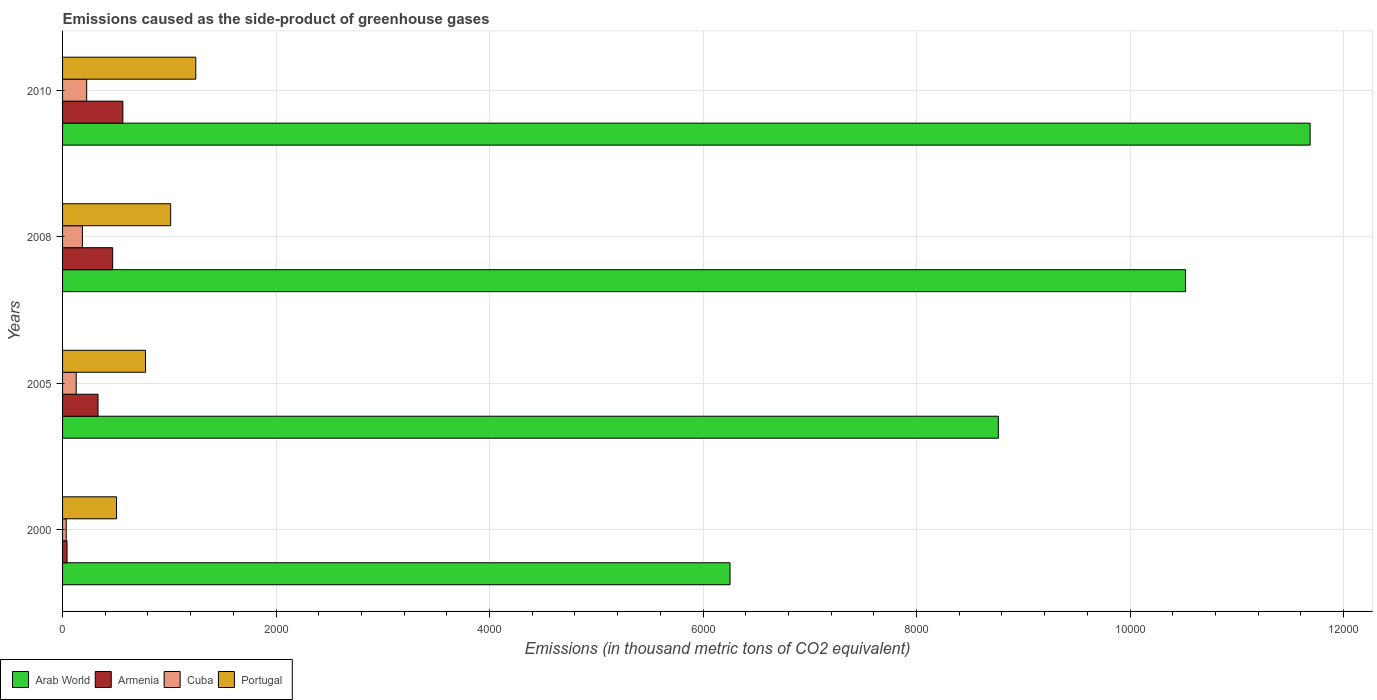How many groups of bars are there?
Keep it short and to the point. 4. What is the label of the 3rd group of bars from the top?
Provide a succinct answer. 2005. What is the emissions caused as the side-product of greenhouse gases in Armenia in 2005?
Ensure brevity in your answer.  332.2. Across all years, what is the maximum emissions caused as the side-product of greenhouse gases in Portugal?
Offer a terse response. 1248. Across all years, what is the minimum emissions caused as the side-product of greenhouse gases in Armenia?
Provide a short and direct response. 42. In which year was the emissions caused as the side-product of greenhouse gases in Cuba maximum?
Ensure brevity in your answer.  2010. What is the total emissions caused as the side-product of greenhouse gases in Cuba in the graph?
Your response must be concise. 573.9. What is the difference between the emissions caused as the side-product of greenhouse gases in Arab World in 2000 and that in 2005?
Offer a very short reply. -2513.8. What is the difference between the emissions caused as the side-product of greenhouse gases in Cuba in 2010 and the emissions caused as the side-product of greenhouse gases in Armenia in 2000?
Offer a terse response. 184. What is the average emissions caused as the side-product of greenhouse gases in Portugal per year?
Your answer should be compact. 885.73. In the year 2008, what is the difference between the emissions caused as the side-product of greenhouse gases in Cuba and emissions caused as the side-product of greenhouse gases in Arab World?
Give a very brief answer. -1.03e+04. In how many years, is the emissions caused as the side-product of greenhouse gases in Portugal greater than 2400 thousand metric tons?
Ensure brevity in your answer.  0. What is the ratio of the emissions caused as the side-product of greenhouse gases in Armenia in 2005 to that in 2008?
Keep it short and to the point. 0.71. What is the difference between the highest and the second highest emissions caused as the side-product of greenhouse gases in Arab World?
Make the answer very short. 1167.8. What is the difference between the highest and the lowest emissions caused as the side-product of greenhouse gases in Arab World?
Your answer should be very brief. 5434.4. In how many years, is the emissions caused as the side-product of greenhouse gases in Armenia greater than the average emissions caused as the side-product of greenhouse gases in Armenia taken over all years?
Your answer should be compact. 2. What does the 2nd bar from the top in 2000 represents?
Offer a very short reply. Cuba. What does the 1st bar from the bottom in 2000 represents?
Ensure brevity in your answer.  Arab World. How many bars are there?
Your response must be concise. 16. Are all the bars in the graph horizontal?
Offer a terse response. Yes. How many years are there in the graph?
Provide a short and direct response. 4. Does the graph contain grids?
Give a very brief answer. Yes. Where does the legend appear in the graph?
Make the answer very short. Bottom left. How many legend labels are there?
Give a very brief answer. 4. What is the title of the graph?
Provide a short and direct response. Emissions caused as the side-product of greenhouse gases. Does "East Asia (all income levels)" appear as one of the legend labels in the graph?
Your answer should be very brief. No. What is the label or title of the X-axis?
Your answer should be very brief. Emissions (in thousand metric tons of CO2 equivalent). What is the label or title of the Y-axis?
Offer a very short reply. Years. What is the Emissions (in thousand metric tons of CO2 equivalent) of Arab World in 2000?
Ensure brevity in your answer.  6252.6. What is the Emissions (in thousand metric tons of CO2 equivalent) in Cuba in 2000?
Your answer should be very brief. 34.2. What is the Emissions (in thousand metric tons of CO2 equivalent) of Portugal in 2000?
Make the answer very short. 505.3. What is the Emissions (in thousand metric tons of CO2 equivalent) in Arab World in 2005?
Keep it short and to the point. 8766.4. What is the Emissions (in thousand metric tons of CO2 equivalent) in Armenia in 2005?
Your answer should be compact. 332.2. What is the Emissions (in thousand metric tons of CO2 equivalent) of Cuba in 2005?
Your response must be concise. 127.8. What is the Emissions (in thousand metric tons of CO2 equivalent) of Portugal in 2005?
Offer a very short reply. 776.9. What is the Emissions (in thousand metric tons of CO2 equivalent) of Arab World in 2008?
Provide a short and direct response. 1.05e+04. What is the Emissions (in thousand metric tons of CO2 equivalent) in Armenia in 2008?
Provide a short and direct response. 469.6. What is the Emissions (in thousand metric tons of CO2 equivalent) of Cuba in 2008?
Provide a succinct answer. 185.9. What is the Emissions (in thousand metric tons of CO2 equivalent) in Portugal in 2008?
Your answer should be very brief. 1012.7. What is the Emissions (in thousand metric tons of CO2 equivalent) in Arab World in 2010?
Make the answer very short. 1.17e+04. What is the Emissions (in thousand metric tons of CO2 equivalent) of Armenia in 2010?
Provide a short and direct response. 565. What is the Emissions (in thousand metric tons of CO2 equivalent) in Cuba in 2010?
Ensure brevity in your answer.  226. What is the Emissions (in thousand metric tons of CO2 equivalent) in Portugal in 2010?
Your answer should be compact. 1248. Across all years, what is the maximum Emissions (in thousand metric tons of CO2 equivalent) of Arab World?
Offer a very short reply. 1.17e+04. Across all years, what is the maximum Emissions (in thousand metric tons of CO2 equivalent) of Armenia?
Keep it short and to the point. 565. Across all years, what is the maximum Emissions (in thousand metric tons of CO2 equivalent) in Cuba?
Provide a succinct answer. 226. Across all years, what is the maximum Emissions (in thousand metric tons of CO2 equivalent) of Portugal?
Provide a short and direct response. 1248. Across all years, what is the minimum Emissions (in thousand metric tons of CO2 equivalent) of Arab World?
Your answer should be very brief. 6252.6. Across all years, what is the minimum Emissions (in thousand metric tons of CO2 equivalent) of Cuba?
Ensure brevity in your answer.  34.2. Across all years, what is the minimum Emissions (in thousand metric tons of CO2 equivalent) in Portugal?
Make the answer very short. 505.3. What is the total Emissions (in thousand metric tons of CO2 equivalent) of Arab World in the graph?
Provide a succinct answer. 3.72e+04. What is the total Emissions (in thousand metric tons of CO2 equivalent) in Armenia in the graph?
Keep it short and to the point. 1408.8. What is the total Emissions (in thousand metric tons of CO2 equivalent) of Cuba in the graph?
Your response must be concise. 573.9. What is the total Emissions (in thousand metric tons of CO2 equivalent) in Portugal in the graph?
Provide a short and direct response. 3542.9. What is the difference between the Emissions (in thousand metric tons of CO2 equivalent) in Arab World in 2000 and that in 2005?
Offer a very short reply. -2513.8. What is the difference between the Emissions (in thousand metric tons of CO2 equivalent) of Armenia in 2000 and that in 2005?
Give a very brief answer. -290.2. What is the difference between the Emissions (in thousand metric tons of CO2 equivalent) of Cuba in 2000 and that in 2005?
Keep it short and to the point. -93.6. What is the difference between the Emissions (in thousand metric tons of CO2 equivalent) in Portugal in 2000 and that in 2005?
Ensure brevity in your answer.  -271.6. What is the difference between the Emissions (in thousand metric tons of CO2 equivalent) of Arab World in 2000 and that in 2008?
Provide a succinct answer. -4266.6. What is the difference between the Emissions (in thousand metric tons of CO2 equivalent) of Armenia in 2000 and that in 2008?
Your answer should be compact. -427.6. What is the difference between the Emissions (in thousand metric tons of CO2 equivalent) in Cuba in 2000 and that in 2008?
Offer a very short reply. -151.7. What is the difference between the Emissions (in thousand metric tons of CO2 equivalent) in Portugal in 2000 and that in 2008?
Your answer should be very brief. -507.4. What is the difference between the Emissions (in thousand metric tons of CO2 equivalent) in Arab World in 2000 and that in 2010?
Offer a very short reply. -5434.4. What is the difference between the Emissions (in thousand metric tons of CO2 equivalent) of Armenia in 2000 and that in 2010?
Give a very brief answer. -523. What is the difference between the Emissions (in thousand metric tons of CO2 equivalent) in Cuba in 2000 and that in 2010?
Provide a short and direct response. -191.8. What is the difference between the Emissions (in thousand metric tons of CO2 equivalent) of Portugal in 2000 and that in 2010?
Give a very brief answer. -742.7. What is the difference between the Emissions (in thousand metric tons of CO2 equivalent) of Arab World in 2005 and that in 2008?
Provide a short and direct response. -1752.8. What is the difference between the Emissions (in thousand metric tons of CO2 equivalent) of Armenia in 2005 and that in 2008?
Keep it short and to the point. -137.4. What is the difference between the Emissions (in thousand metric tons of CO2 equivalent) in Cuba in 2005 and that in 2008?
Offer a terse response. -58.1. What is the difference between the Emissions (in thousand metric tons of CO2 equivalent) of Portugal in 2005 and that in 2008?
Keep it short and to the point. -235.8. What is the difference between the Emissions (in thousand metric tons of CO2 equivalent) in Arab World in 2005 and that in 2010?
Give a very brief answer. -2920.6. What is the difference between the Emissions (in thousand metric tons of CO2 equivalent) of Armenia in 2005 and that in 2010?
Provide a short and direct response. -232.8. What is the difference between the Emissions (in thousand metric tons of CO2 equivalent) in Cuba in 2005 and that in 2010?
Offer a very short reply. -98.2. What is the difference between the Emissions (in thousand metric tons of CO2 equivalent) of Portugal in 2005 and that in 2010?
Your response must be concise. -471.1. What is the difference between the Emissions (in thousand metric tons of CO2 equivalent) of Arab World in 2008 and that in 2010?
Make the answer very short. -1167.8. What is the difference between the Emissions (in thousand metric tons of CO2 equivalent) in Armenia in 2008 and that in 2010?
Your answer should be compact. -95.4. What is the difference between the Emissions (in thousand metric tons of CO2 equivalent) of Cuba in 2008 and that in 2010?
Give a very brief answer. -40.1. What is the difference between the Emissions (in thousand metric tons of CO2 equivalent) in Portugal in 2008 and that in 2010?
Ensure brevity in your answer.  -235.3. What is the difference between the Emissions (in thousand metric tons of CO2 equivalent) of Arab World in 2000 and the Emissions (in thousand metric tons of CO2 equivalent) of Armenia in 2005?
Your answer should be very brief. 5920.4. What is the difference between the Emissions (in thousand metric tons of CO2 equivalent) in Arab World in 2000 and the Emissions (in thousand metric tons of CO2 equivalent) in Cuba in 2005?
Offer a terse response. 6124.8. What is the difference between the Emissions (in thousand metric tons of CO2 equivalent) in Arab World in 2000 and the Emissions (in thousand metric tons of CO2 equivalent) in Portugal in 2005?
Provide a short and direct response. 5475.7. What is the difference between the Emissions (in thousand metric tons of CO2 equivalent) of Armenia in 2000 and the Emissions (in thousand metric tons of CO2 equivalent) of Cuba in 2005?
Ensure brevity in your answer.  -85.8. What is the difference between the Emissions (in thousand metric tons of CO2 equivalent) of Armenia in 2000 and the Emissions (in thousand metric tons of CO2 equivalent) of Portugal in 2005?
Give a very brief answer. -734.9. What is the difference between the Emissions (in thousand metric tons of CO2 equivalent) in Cuba in 2000 and the Emissions (in thousand metric tons of CO2 equivalent) in Portugal in 2005?
Give a very brief answer. -742.7. What is the difference between the Emissions (in thousand metric tons of CO2 equivalent) of Arab World in 2000 and the Emissions (in thousand metric tons of CO2 equivalent) of Armenia in 2008?
Your answer should be very brief. 5783. What is the difference between the Emissions (in thousand metric tons of CO2 equivalent) in Arab World in 2000 and the Emissions (in thousand metric tons of CO2 equivalent) in Cuba in 2008?
Provide a succinct answer. 6066.7. What is the difference between the Emissions (in thousand metric tons of CO2 equivalent) in Arab World in 2000 and the Emissions (in thousand metric tons of CO2 equivalent) in Portugal in 2008?
Give a very brief answer. 5239.9. What is the difference between the Emissions (in thousand metric tons of CO2 equivalent) in Armenia in 2000 and the Emissions (in thousand metric tons of CO2 equivalent) in Cuba in 2008?
Ensure brevity in your answer.  -143.9. What is the difference between the Emissions (in thousand metric tons of CO2 equivalent) of Armenia in 2000 and the Emissions (in thousand metric tons of CO2 equivalent) of Portugal in 2008?
Provide a short and direct response. -970.7. What is the difference between the Emissions (in thousand metric tons of CO2 equivalent) in Cuba in 2000 and the Emissions (in thousand metric tons of CO2 equivalent) in Portugal in 2008?
Provide a succinct answer. -978.5. What is the difference between the Emissions (in thousand metric tons of CO2 equivalent) of Arab World in 2000 and the Emissions (in thousand metric tons of CO2 equivalent) of Armenia in 2010?
Ensure brevity in your answer.  5687.6. What is the difference between the Emissions (in thousand metric tons of CO2 equivalent) of Arab World in 2000 and the Emissions (in thousand metric tons of CO2 equivalent) of Cuba in 2010?
Make the answer very short. 6026.6. What is the difference between the Emissions (in thousand metric tons of CO2 equivalent) in Arab World in 2000 and the Emissions (in thousand metric tons of CO2 equivalent) in Portugal in 2010?
Your response must be concise. 5004.6. What is the difference between the Emissions (in thousand metric tons of CO2 equivalent) in Armenia in 2000 and the Emissions (in thousand metric tons of CO2 equivalent) in Cuba in 2010?
Your answer should be compact. -184. What is the difference between the Emissions (in thousand metric tons of CO2 equivalent) of Armenia in 2000 and the Emissions (in thousand metric tons of CO2 equivalent) of Portugal in 2010?
Your response must be concise. -1206. What is the difference between the Emissions (in thousand metric tons of CO2 equivalent) in Cuba in 2000 and the Emissions (in thousand metric tons of CO2 equivalent) in Portugal in 2010?
Your answer should be very brief. -1213.8. What is the difference between the Emissions (in thousand metric tons of CO2 equivalent) of Arab World in 2005 and the Emissions (in thousand metric tons of CO2 equivalent) of Armenia in 2008?
Keep it short and to the point. 8296.8. What is the difference between the Emissions (in thousand metric tons of CO2 equivalent) in Arab World in 2005 and the Emissions (in thousand metric tons of CO2 equivalent) in Cuba in 2008?
Ensure brevity in your answer.  8580.5. What is the difference between the Emissions (in thousand metric tons of CO2 equivalent) of Arab World in 2005 and the Emissions (in thousand metric tons of CO2 equivalent) of Portugal in 2008?
Provide a short and direct response. 7753.7. What is the difference between the Emissions (in thousand metric tons of CO2 equivalent) of Armenia in 2005 and the Emissions (in thousand metric tons of CO2 equivalent) of Cuba in 2008?
Make the answer very short. 146.3. What is the difference between the Emissions (in thousand metric tons of CO2 equivalent) of Armenia in 2005 and the Emissions (in thousand metric tons of CO2 equivalent) of Portugal in 2008?
Ensure brevity in your answer.  -680.5. What is the difference between the Emissions (in thousand metric tons of CO2 equivalent) in Cuba in 2005 and the Emissions (in thousand metric tons of CO2 equivalent) in Portugal in 2008?
Keep it short and to the point. -884.9. What is the difference between the Emissions (in thousand metric tons of CO2 equivalent) in Arab World in 2005 and the Emissions (in thousand metric tons of CO2 equivalent) in Armenia in 2010?
Your answer should be compact. 8201.4. What is the difference between the Emissions (in thousand metric tons of CO2 equivalent) of Arab World in 2005 and the Emissions (in thousand metric tons of CO2 equivalent) of Cuba in 2010?
Ensure brevity in your answer.  8540.4. What is the difference between the Emissions (in thousand metric tons of CO2 equivalent) in Arab World in 2005 and the Emissions (in thousand metric tons of CO2 equivalent) in Portugal in 2010?
Keep it short and to the point. 7518.4. What is the difference between the Emissions (in thousand metric tons of CO2 equivalent) of Armenia in 2005 and the Emissions (in thousand metric tons of CO2 equivalent) of Cuba in 2010?
Provide a succinct answer. 106.2. What is the difference between the Emissions (in thousand metric tons of CO2 equivalent) in Armenia in 2005 and the Emissions (in thousand metric tons of CO2 equivalent) in Portugal in 2010?
Your response must be concise. -915.8. What is the difference between the Emissions (in thousand metric tons of CO2 equivalent) in Cuba in 2005 and the Emissions (in thousand metric tons of CO2 equivalent) in Portugal in 2010?
Your response must be concise. -1120.2. What is the difference between the Emissions (in thousand metric tons of CO2 equivalent) in Arab World in 2008 and the Emissions (in thousand metric tons of CO2 equivalent) in Armenia in 2010?
Ensure brevity in your answer.  9954.2. What is the difference between the Emissions (in thousand metric tons of CO2 equivalent) of Arab World in 2008 and the Emissions (in thousand metric tons of CO2 equivalent) of Cuba in 2010?
Offer a terse response. 1.03e+04. What is the difference between the Emissions (in thousand metric tons of CO2 equivalent) in Arab World in 2008 and the Emissions (in thousand metric tons of CO2 equivalent) in Portugal in 2010?
Your answer should be compact. 9271.2. What is the difference between the Emissions (in thousand metric tons of CO2 equivalent) in Armenia in 2008 and the Emissions (in thousand metric tons of CO2 equivalent) in Cuba in 2010?
Your answer should be compact. 243.6. What is the difference between the Emissions (in thousand metric tons of CO2 equivalent) of Armenia in 2008 and the Emissions (in thousand metric tons of CO2 equivalent) of Portugal in 2010?
Offer a terse response. -778.4. What is the difference between the Emissions (in thousand metric tons of CO2 equivalent) in Cuba in 2008 and the Emissions (in thousand metric tons of CO2 equivalent) in Portugal in 2010?
Provide a short and direct response. -1062.1. What is the average Emissions (in thousand metric tons of CO2 equivalent) in Arab World per year?
Provide a succinct answer. 9306.3. What is the average Emissions (in thousand metric tons of CO2 equivalent) of Armenia per year?
Offer a very short reply. 352.2. What is the average Emissions (in thousand metric tons of CO2 equivalent) of Cuba per year?
Provide a short and direct response. 143.47. What is the average Emissions (in thousand metric tons of CO2 equivalent) of Portugal per year?
Provide a succinct answer. 885.73. In the year 2000, what is the difference between the Emissions (in thousand metric tons of CO2 equivalent) in Arab World and Emissions (in thousand metric tons of CO2 equivalent) in Armenia?
Your answer should be very brief. 6210.6. In the year 2000, what is the difference between the Emissions (in thousand metric tons of CO2 equivalent) of Arab World and Emissions (in thousand metric tons of CO2 equivalent) of Cuba?
Offer a terse response. 6218.4. In the year 2000, what is the difference between the Emissions (in thousand metric tons of CO2 equivalent) of Arab World and Emissions (in thousand metric tons of CO2 equivalent) of Portugal?
Make the answer very short. 5747.3. In the year 2000, what is the difference between the Emissions (in thousand metric tons of CO2 equivalent) in Armenia and Emissions (in thousand metric tons of CO2 equivalent) in Portugal?
Keep it short and to the point. -463.3. In the year 2000, what is the difference between the Emissions (in thousand metric tons of CO2 equivalent) in Cuba and Emissions (in thousand metric tons of CO2 equivalent) in Portugal?
Offer a terse response. -471.1. In the year 2005, what is the difference between the Emissions (in thousand metric tons of CO2 equivalent) of Arab World and Emissions (in thousand metric tons of CO2 equivalent) of Armenia?
Keep it short and to the point. 8434.2. In the year 2005, what is the difference between the Emissions (in thousand metric tons of CO2 equivalent) of Arab World and Emissions (in thousand metric tons of CO2 equivalent) of Cuba?
Offer a very short reply. 8638.6. In the year 2005, what is the difference between the Emissions (in thousand metric tons of CO2 equivalent) of Arab World and Emissions (in thousand metric tons of CO2 equivalent) of Portugal?
Provide a short and direct response. 7989.5. In the year 2005, what is the difference between the Emissions (in thousand metric tons of CO2 equivalent) of Armenia and Emissions (in thousand metric tons of CO2 equivalent) of Cuba?
Provide a short and direct response. 204.4. In the year 2005, what is the difference between the Emissions (in thousand metric tons of CO2 equivalent) in Armenia and Emissions (in thousand metric tons of CO2 equivalent) in Portugal?
Provide a short and direct response. -444.7. In the year 2005, what is the difference between the Emissions (in thousand metric tons of CO2 equivalent) in Cuba and Emissions (in thousand metric tons of CO2 equivalent) in Portugal?
Your answer should be very brief. -649.1. In the year 2008, what is the difference between the Emissions (in thousand metric tons of CO2 equivalent) of Arab World and Emissions (in thousand metric tons of CO2 equivalent) of Armenia?
Offer a very short reply. 1.00e+04. In the year 2008, what is the difference between the Emissions (in thousand metric tons of CO2 equivalent) in Arab World and Emissions (in thousand metric tons of CO2 equivalent) in Cuba?
Provide a short and direct response. 1.03e+04. In the year 2008, what is the difference between the Emissions (in thousand metric tons of CO2 equivalent) of Arab World and Emissions (in thousand metric tons of CO2 equivalent) of Portugal?
Provide a succinct answer. 9506.5. In the year 2008, what is the difference between the Emissions (in thousand metric tons of CO2 equivalent) in Armenia and Emissions (in thousand metric tons of CO2 equivalent) in Cuba?
Give a very brief answer. 283.7. In the year 2008, what is the difference between the Emissions (in thousand metric tons of CO2 equivalent) of Armenia and Emissions (in thousand metric tons of CO2 equivalent) of Portugal?
Offer a very short reply. -543.1. In the year 2008, what is the difference between the Emissions (in thousand metric tons of CO2 equivalent) of Cuba and Emissions (in thousand metric tons of CO2 equivalent) of Portugal?
Offer a terse response. -826.8. In the year 2010, what is the difference between the Emissions (in thousand metric tons of CO2 equivalent) in Arab World and Emissions (in thousand metric tons of CO2 equivalent) in Armenia?
Provide a succinct answer. 1.11e+04. In the year 2010, what is the difference between the Emissions (in thousand metric tons of CO2 equivalent) in Arab World and Emissions (in thousand metric tons of CO2 equivalent) in Cuba?
Give a very brief answer. 1.15e+04. In the year 2010, what is the difference between the Emissions (in thousand metric tons of CO2 equivalent) in Arab World and Emissions (in thousand metric tons of CO2 equivalent) in Portugal?
Offer a very short reply. 1.04e+04. In the year 2010, what is the difference between the Emissions (in thousand metric tons of CO2 equivalent) of Armenia and Emissions (in thousand metric tons of CO2 equivalent) of Cuba?
Your response must be concise. 339. In the year 2010, what is the difference between the Emissions (in thousand metric tons of CO2 equivalent) in Armenia and Emissions (in thousand metric tons of CO2 equivalent) in Portugal?
Provide a succinct answer. -683. In the year 2010, what is the difference between the Emissions (in thousand metric tons of CO2 equivalent) in Cuba and Emissions (in thousand metric tons of CO2 equivalent) in Portugal?
Your answer should be very brief. -1022. What is the ratio of the Emissions (in thousand metric tons of CO2 equivalent) of Arab World in 2000 to that in 2005?
Offer a very short reply. 0.71. What is the ratio of the Emissions (in thousand metric tons of CO2 equivalent) in Armenia in 2000 to that in 2005?
Ensure brevity in your answer.  0.13. What is the ratio of the Emissions (in thousand metric tons of CO2 equivalent) of Cuba in 2000 to that in 2005?
Give a very brief answer. 0.27. What is the ratio of the Emissions (in thousand metric tons of CO2 equivalent) in Portugal in 2000 to that in 2005?
Keep it short and to the point. 0.65. What is the ratio of the Emissions (in thousand metric tons of CO2 equivalent) of Arab World in 2000 to that in 2008?
Make the answer very short. 0.59. What is the ratio of the Emissions (in thousand metric tons of CO2 equivalent) in Armenia in 2000 to that in 2008?
Ensure brevity in your answer.  0.09. What is the ratio of the Emissions (in thousand metric tons of CO2 equivalent) in Cuba in 2000 to that in 2008?
Give a very brief answer. 0.18. What is the ratio of the Emissions (in thousand metric tons of CO2 equivalent) in Portugal in 2000 to that in 2008?
Make the answer very short. 0.5. What is the ratio of the Emissions (in thousand metric tons of CO2 equivalent) in Arab World in 2000 to that in 2010?
Ensure brevity in your answer.  0.54. What is the ratio of the Emissions (in thousand metric tons of CO2 equivalent) of Armenia in 2000 to that in 2010?
Offer a terse response. 0.07. What is the ratio of the Emissions (in thousand metric tons of CO2 equivalent) of Cuba in 2000 to that in 2010?
Give a very brief answer. 0.15. What is the ratio of the Emissions (in thousand metric tons of CO2 equivalent) of Portugal in 2000 to that in 2010?
Ensure brevity in your answer.  0.4. What is the ratio of the Emissions (in thousand metric tons of CO2 equivalent) of Arab World in 2005 to that in 2008?
Provide a short and direct response. 0.83. What is the ratio of the Emissions (in thousand metric tons of CO2 equivalent) of Armenia in 2005 to that in 2008?
Provide a succinct answer. 0.71. What is the ratio of the Emissions (in thousand metric tons of CO2 equivalent) in Cuba in 2005 to that in 2008?
Give a very brief answer. 0.69. What is the ratio of the Emissions (in thousand metric tons of CO2 equivalent) of Portugal in 2005 to that in 2008?
Provide a succinct answer. 0.77. What is the ratio of the Emissions (in thousand metric tons of CO2 equivalent) of Arab World in 2005 to that in 2010?
Your answer should be compact. 0.75. What is the ratio of the Emissions (in thousand metric tons of CO2 equivalent) of Armenia in 2005 to that in 2010?
Provide a short and direct response. 0.59. What is the ratio of the Emissions (in thousand metric tons of CO2 equivalent) of Cuba in 2005 to that in 2010?
Offer a very short reply. 0.57. What is the ratio of the Emissions (in thousand metric tons of CO2 equivalent) in Portugal in 2005 to that in 2010?
Ensure brevity in your answer.  0.62. What is the ratio of the Emissions (in thousand metric tons of CO2 equivalent) of Arab World in 2008 to that in 2010?
Make the answer very short. 0.9. What is the ratio of the Emissions (in thousand metric tons of CO2 equivalent) of Armenia in 2008 to that in 2010?
Keep it short and to the point. 0.83. What is the ratio of the Emissions (in thousand metric tons of CO2 equivalent) of Cuba in 2008 to that in 2010?
Give a very brief answer. 0.82. What is the ratio of the Emissions (in thousand metric tons of CO2 equivalent) in Portugal in 2008 to that in 2010?
Keep it short and to the point. 0.81. What is the difference between the highest and the second highest Emissions (in thousand metric tons of CO2 equivalent) in Arab World?
Ensure brevity in your answer.  1167.8. What is the difference between the highest and the second highest Emissions (in thousand metric tons of CO2 equivalent) of Armenia?
Make the answer very short. 95.4. What is the difference between the highest and the second highest Emissions (in thousand metric tons of CO2 equivalent) of Cuba?
Keep it short and to the point. 40.1. What is the difference between the highest and the second highest Emissions (in thousand metric tons of CO2 equivalent) of Portugal?
Provide a short and direct response. 235.3. What is the difference between the highest and the lowest Emissions (in thousand metric tons of CO2 equivalent) in Arab World?
Your answer should be very brief. 5434.4. What is the difference between the highest and the lowest Emissions (in thousand metric tons of CO2 equivalent) of Armenia?
Your answer should be compact. 523. What is the difference between the highest and the lowest Emissions (in thousand metric tons of CO2 equivalent) of Cuba?
Give a very brief answer. 191.8. What is the difference between the highest and the lowest Emissions (in thousand metric tons of CO2 equivalent) of Portugal?
Your answer should be very brief. 742.7. 